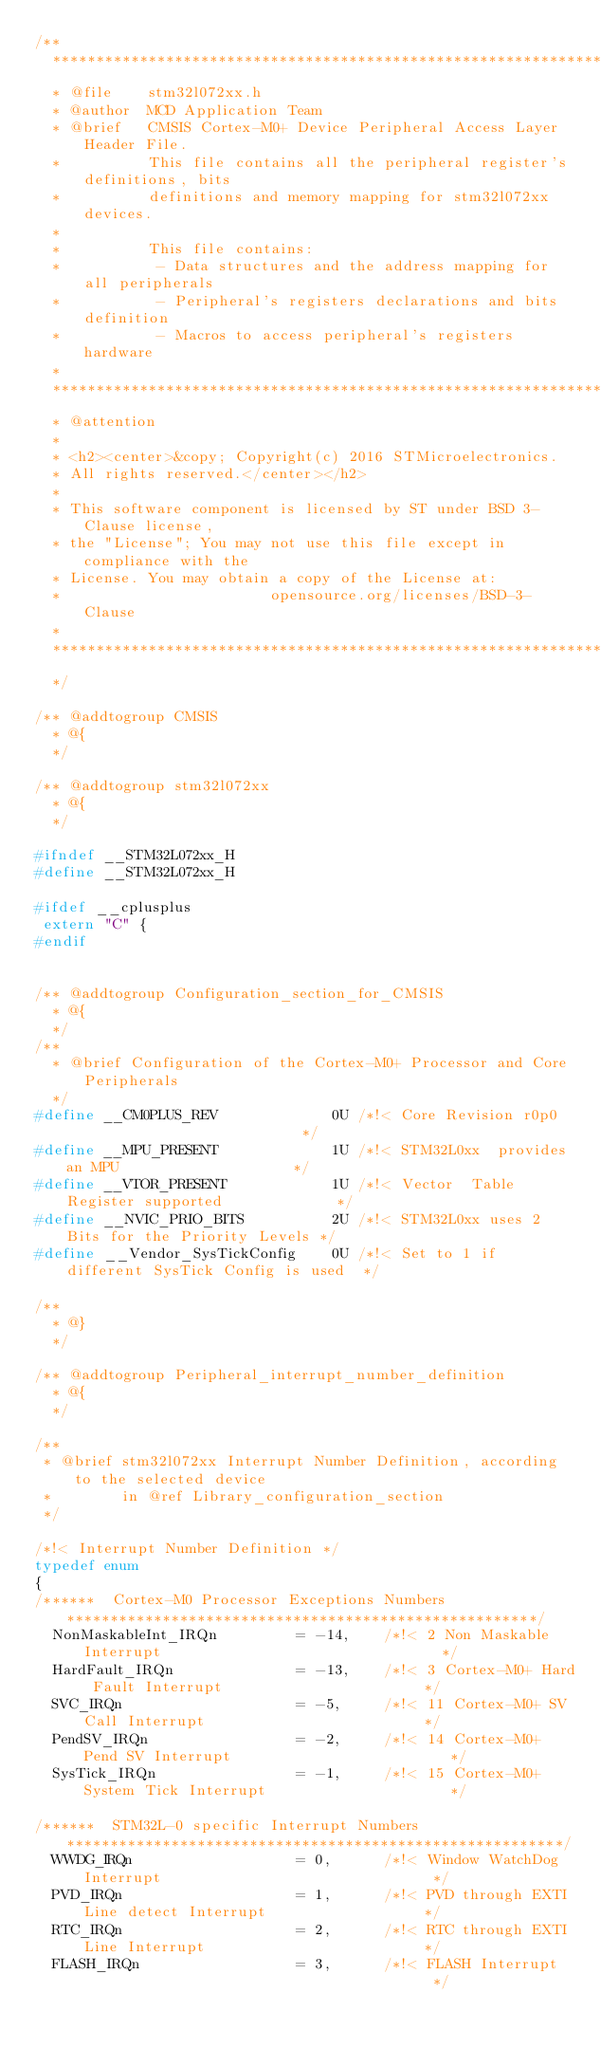<code> <loc_0><loc_0><loc_500><loc_500><_C_>/**
  ******************************************************************************
  * @file    stm32l072xx.h
  * @author  MCD Application Team
  * @brief   CMSIS Cortex-M0+ Device Peripheral Access Layer Header File.
  *          This file contains all the peripheral register's definitions, bits
  *          definitions and memory mapping for stm32l072xx devices.
  *
  *          This file contains:
  *           - Data structures and the address mapping for all peripherals
  *           - Peripheral's registers declarations and bits definition
  *           - Macros to access peripheral's registers hardware
  *
  ******************************************************************************
  * @attention
  *
  * <h2><center>&copy; Copyright(c) 2016 STMicroelectronics.
  * All rights reserved.</center></h2>
  *
  * This software component is licensed by ST under BSD 3-Clause license,
  * the "License"; You may not use this file except in compliance with the
  * License. You may obtain a copy of the License at:
  *                        opensource.org/licenses/BSD-3-Clause
  *
  ******************************************************************************
  */

/** @addtogroup CMSIS
  * @{
  */

/** @addtogroup stm32l072xx
  * @{
  */

#ifndef __STM32L072xx_H
#define __STM32L072xx_H

#ifdef __cplusplus
 extern "C" {
#endif


/** @addtogroup Configuration_section_for_CMSIS
  * @{
  */
/**
  * @brief Configuration of the Cortex-M0+ Processor and Core Peripherals
  */
#define __CM0PLUS_REV             0U /*!< Core Revision r0p0                            */
#define __MPU_PRESENT             1U /*!< STM32L0xx  provides an MPU                    */
#define __VTOR_PRESENT            1U /*!< Vector  Table  Register supported             */
#define __NVIC_PRIO_BITS          2U /*!< STM32L0xx uses 2 Bits for the Priority Levels */
#define __Vendor_SysTickConfig    0U /*!< Set to 1 if different SysTick Config is used  */

/**
  * @}
  */

/** @addtogroup Peripheral_interrupt_number_definition
  * @{
  */

/**
 * @brief stm32l072xx Interrupt Number Definition, according to the selected device
 *        in @ref Library_configuration_section
 */

/*!< Interrupt Number Definition */
typedef enum
{
/******  Cortex-M0 Processor Exceptions Numbers ******************************************************/
  NonMaskableInt_IRQn         = -14,    /*!< 2 Non Maskable Interrupt                                */
  HardFault_IRQn              = -13,    /*!< 3 Cortex-M0+ Hard Fault Interrupt                       */
  SVC_IRQn                    = -5,     /*!< 11 Cortex-M0+ SV Call Interrupt                         */
  PendSV_IRQn                 = -2,     /*!< 14 Cortex-M0+ Pend SV Interrupt                         */
  SysTick_IRQn                = -1,     /*!< 15 Cortex-M0+ System Tick Interrupt                     */

/******  STM32L-0 specific Interrupt Numbers *********************************************************/
  WWDG_IRQn                   = 0,      /*!< Window WatchDog Interrupt                               */
  PVD_IRQn                    = 1,      /*!< PVD through EXTI Line detect Interrupt                  */
  RTC_IRQn                    = 2,      /*!< RTC through EXTI Line Interrupt                         */
  FLASH_IRQn                  = 3,      /*!< FLASH Interrupt                                         */</code> 